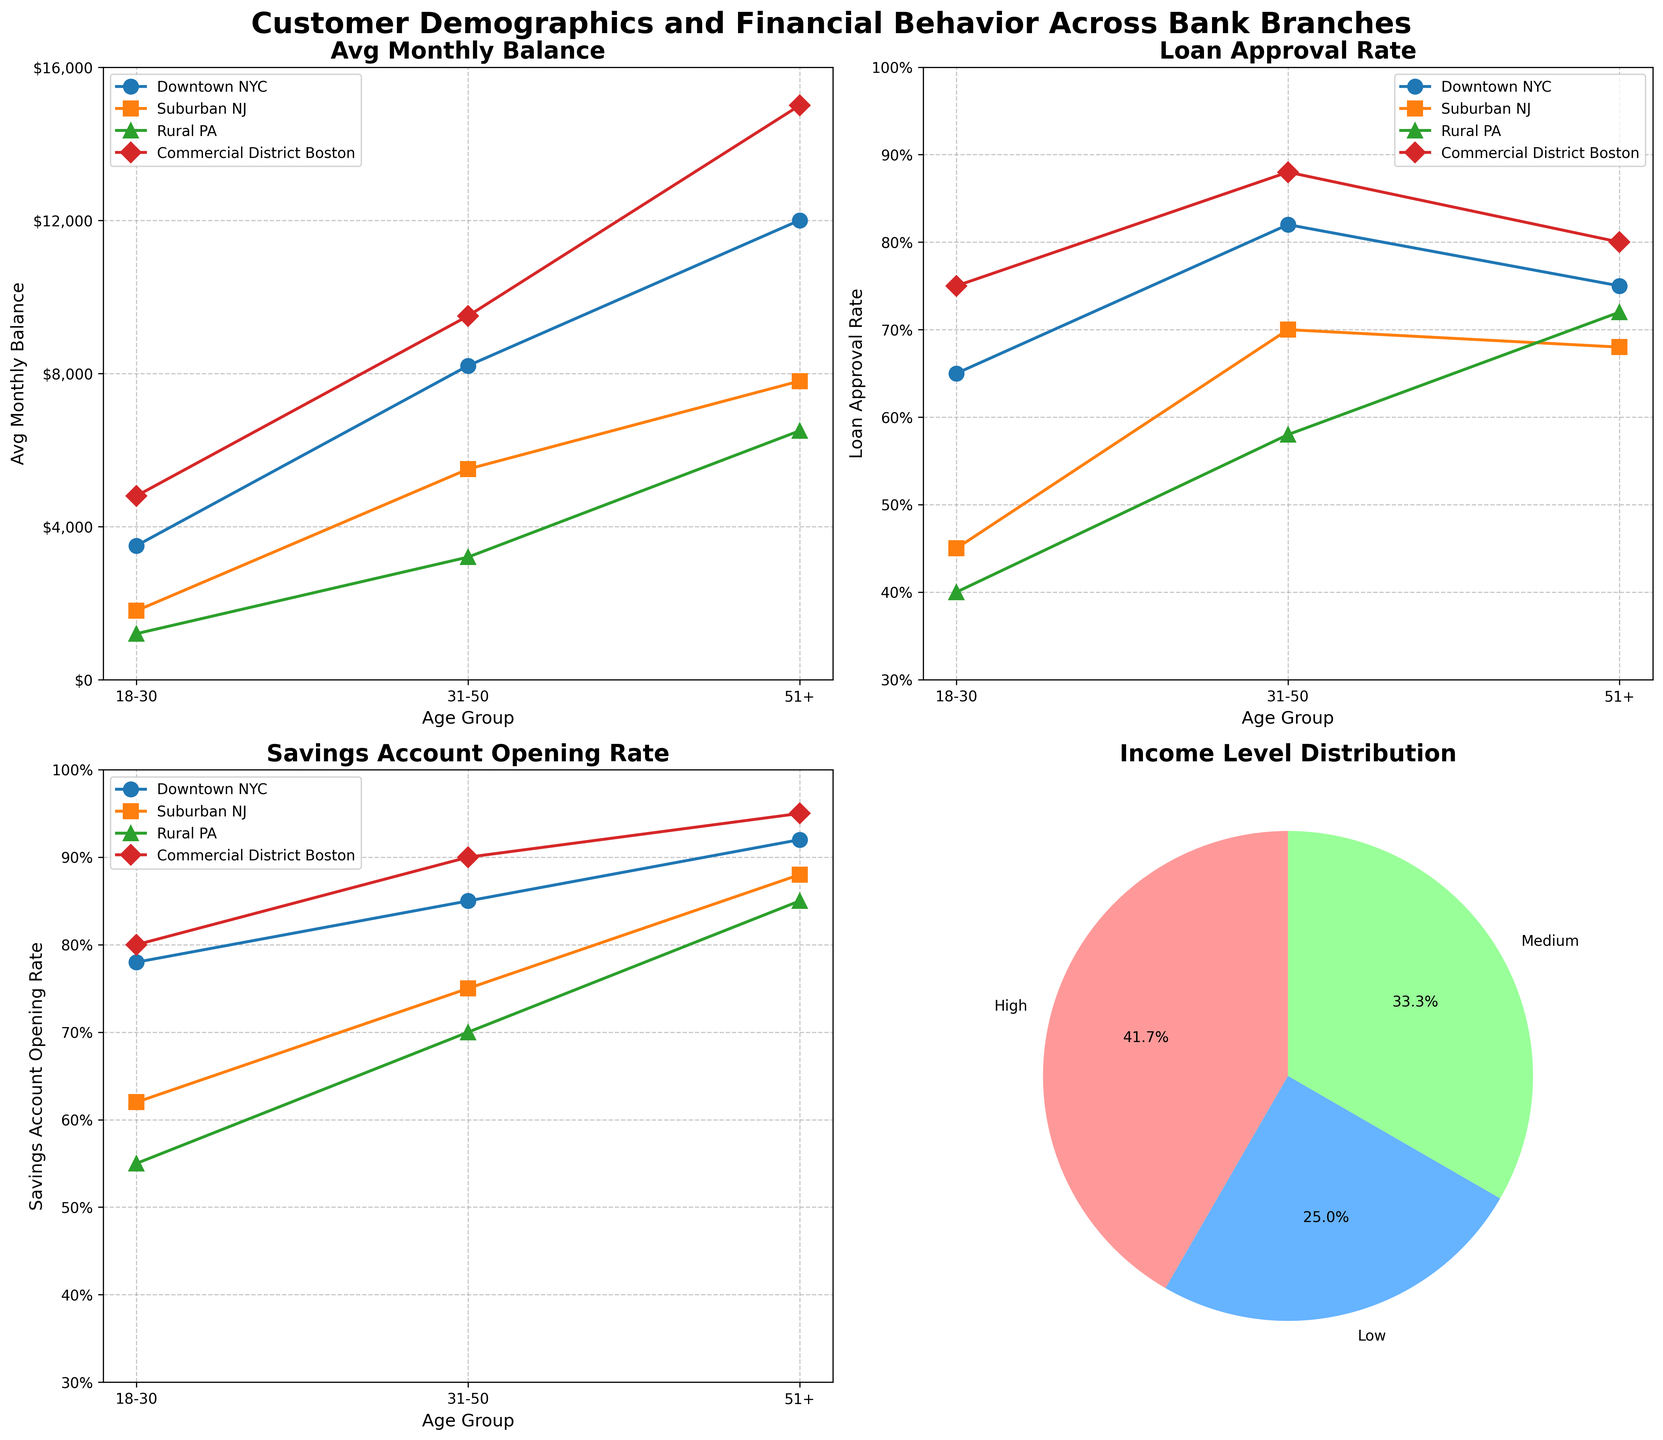What's the title of the figure? The title is usually the most prominent text and is placed at the top of the figure. Observing the top part of the figure will give the title.
Answer: Customer Demographics and Financial Behavior Across Bank Branches How does the average monthly balance vary across age groups in Downtown NYC? Look at the specific subplot labeled "Avg Monthly Balance" and trace the plotted line for the Downtown NYC branch across different age groups. The Downtown NYC branch uses a specific marker (circle) and color as indicated in the legend.
Answer: 18-30: $3,500, 31-50: $8,200, 51+: $12,000 Which branch has the highest loan approval rate for the age group 31-50? Find the subplot titled "Loan Approval Rate" and look specifically at the data points for the age group 31-50 across all branches. Compare the values.
Answer: Commercial District Boston What is the general trend for the savings account opening rate among customers aged 51+? Look at the subplot titled "Savings Account Opening Rate" and observe how data points for the age group 51+ (the end of each line) compare across different branches.
Answer: It generally increases with age, peaking at 95% in Commercial District Boston Compare the average monthly balance of the 18-30 age group in Downtown NYC and the Commercial District Boston. Which is higher? Refer to the "Avg Monthly Balance" subplot and compare the respective data points for Downtown NYC and Commercial District Boston in the 18-30 age group.
Answer: Commercial District Boston How does the loan approval rate in Suburban NJ for the age groups 31-50 and 51+ compare? Examine the subplot labeled "Loan Approval Rate" and locate the corresponding data points for Suburban NJ for the age groups 31-50 and 51+. Compare the values.
Answer: 31-50: 70%, 51+: 68% What's the income level distribution in terms of percentages? Locate the pie chart in the bottom-right subplot titled "Income Level Distribution". The chart segments represent different income levels and their respective percentages. Read the labels for the values.
Answer: Low: 41.7%, Medium: 25%, High: 33.3% Which age group in the Rural PA branch has the highest average monthly balance? Refer to the "Avg Monthly Balance" subplot and trace the line or data points for the Rural PA branch for each age group. Identify the age group with the highest value.
Answer: 51+ In which branch does the 18-30 age group have the highest loan approval rate? Look at the "Loan Approval Rate" subplot and examine the data points for the 18-30 age group across all branches. Identify the branch with the highest rate.
Answer: Commercial District Boston What's the difference in savings account opening rate between Downtown NYC and Suburban NJ for the age group 18-30? Look at the "Savings Account Opening Rate" subplot and find the data points for Downtown NYC and Suburban NJ within the 18-30 age group. Subtract the smaller rate from the larger rate to find the difference.
Answer: 16% 